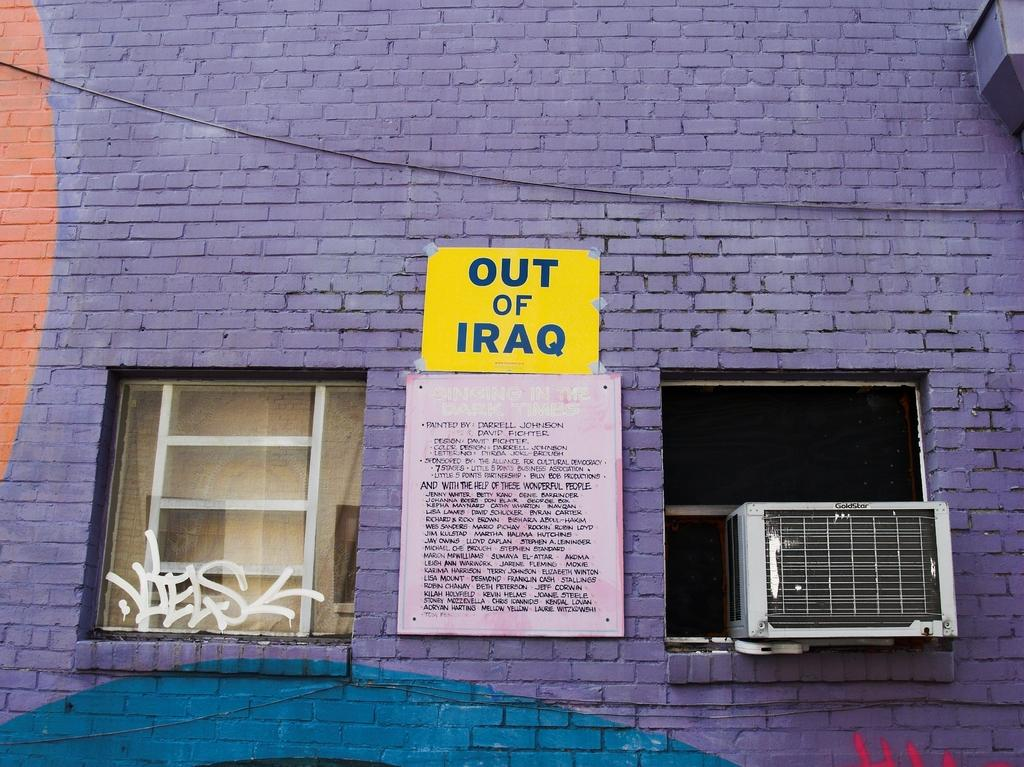What type of material is used to construct the wall in the image? The wall in the image is made of bricks. What is attached to the wall? There is a wire and posters on the wall. Are there any openings in the wall? Yes, there are windows on the wall. What device is mounted on the wall? There is an air conditioner on the wall. Can you see any dogs or a farm in the image? No, there are no dogs or a farm present in the image. What type of rake is being used to clean the bricks on the wall? There is no rake visible in the image, and the bricks on the wall do not require cleaning. 